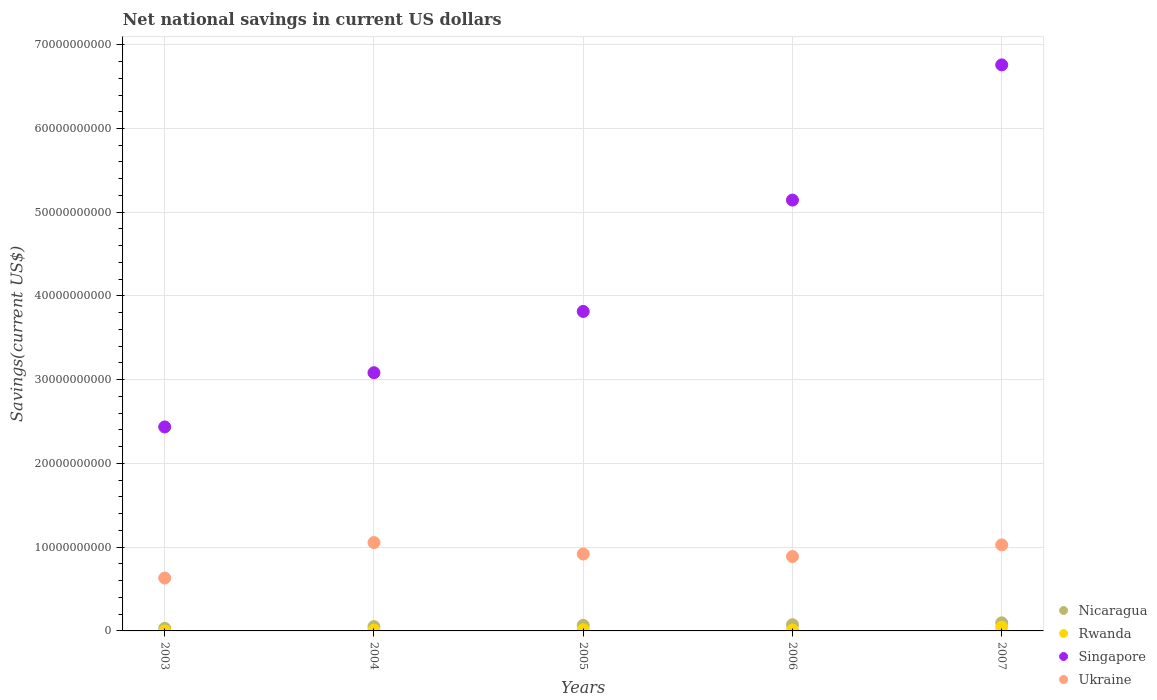What is the net national savings in Ukraine in 2006?
Make the answer very short. 8.88e+09. Across all years, what is the maximum net national savings in Rwanda?
Provide a short and direct response. 4.46e+08. Across all years, what is the minimum net national savings in Ukraine?
Provide a succinct answer. 6.32e+09. What is the total net national savings in Nicaragua in the graph?
Your answer should be compact. 3.19e+09. What is the difference between the net national savings in Singapore in 2003 and that in 2006?
Your answer should be compact. -2.71e+1. What is the difference between the net national savings in Nicaragua in 2006 and the net national savings in Rwanda in 2004?
Provide a short and direct response. 6.41e+08. What is the average net national savings in Ukraine per year?
Give a very brief answer. 9.04e+09. In the year 2006, what is the difference between the net national savings in Ukraine and net national savings in Nicaragua?
Ensure brevity in your answer.  8.14e+09. In how many years, is the net national savings in Ukraine greater than 30000000000 US$?
Your answer should be very brief. 0. What is the ratio of the net national savings in Ukraine in 2003 to that in 2007?
Offer a terse response. 0.61. What is the difference between the highest and the second highest net national savings in Nicaragua?
Your answer should be very brief. 2.22e+08. What is the difference between the highest and the lowest net national savings in Singapore?
Provide a succinct answer. 4.32e+1. Is the sum of the net national savings in Rwanda in 2004 and 2007 greater than the maximum net national savings in Ukraine across all years?
Offer a very short reply. No. Is it the case that in every year, the sum of the net national savings in Nicaragua and net national savings in Rwanda  is greater than the net national savings in Singapore?
Your answer should be very brief. No. How many dotlines are there?
Give a very brief answer. 4. What is the difference between two consecutive major ticks on the Y-axis?
Keep it short and to the point. 1.00e+1. Are the values on the major ticks of Y-axis written in scientific E-notation?
Ensure brevity in your answer.  No. Does the graph contain grids?
Make the answer very short. Yes. How many legend labels are there?
Keep it short and to the point. 4. How are the legend labels stacked?
Provide a succinct answer. Vertical. What is the title of the graph?
Keep it short and to the point. Net national savings in current US dollars. Does "Somalia" appear as one of the legend labels in the graph?
Ensure brevity in your answer.  No. What is the label or title of the Y-axis?
Offer a terse response. Savings(current US$). What is the Savings(current US$) of Nicaragua in 2003?
Offer a very short reply. 3.01e+08. What is the Savings(current US$) in Singapore in 2003?
Offer a terse response. 2.44e+1. What is the Savings(current US$) of Ukraine in 2003?
Make the answer very short. 6.32e+09. What is the Savings(current US$) in Nicaragua in 2004?
Ensure brevity in your answer.  5.14e+08. What is the Savings(current US$) of Rwanda in 2004?
Offer a terse response. 1.01e+08. What is the Savings(current US$) of Singapore in 2004?
Give a very brief answer. 3.08e+1. What is the Savings(current US$) in Ukraine in 2004?
Provide a succinct answer. 1.06e+1. What is the Savings(current US$) of Nicaragua in 2005?
Give a very brief answer. 6.65e+08. What is the Savings(current US$) of Rwanda in 2005?
Your response must be concise. 1.34e+08. What is the Savings(current US$) in Singapore in 2005?
Your response must be concise. 3.82e+1. What is the Savings(current US$) in Ukraine in 2005?
Your answer should be very brief. 9.18e+09. What is the Savings(current US$) of Nicaragua in 2006?
Provide a succinct answer. 7.42e+08. What is the Savings(current US$) in Rwanda in 2006?
Offer a very short reply. 9.64e+07. What is the Savings(current US$) in Singapore in 2006?
Keep it short and to the point. 5.14e+1. What is the Savings(current US$) of Ukraine in 2006?
Your answer should be compact. 8.88e+09. What is the Savings(current US$) of Nicaragua in 2007?
Keep it short and to the point. 9.64e+08. What is the Savings(current US$) of Rwanda in 2007?
Make the answer very short. 4.46e+08. What is the Savings(current US$) in Singapore in 2007?
Keep it short and to the point. 6.76e+1. What is the Savings(current US$) of Ukraine in 2007?
Provide a short and direct response. 1.03e+1. Across all years, what is the maximum Savings(current US$) in Nicaragua?
Keep it short and to the point. 9.64e+08. Across all years, what is the maximum Savings(current US$) in Rwanda?
Your response must be concise. 4.46e+08. Across all years, what is the maximum Savings(current US$) in Singapore?
Provide a short and direct response. 6.76e+1. Across all years, what is the maximum Savings(current US$) in Ukraine?
Offer a very short reply. 1.06e+1. Across all years, what is the minimum Savings(current US$) in Nicaragua?
Provide a short and direct response. 3.01e+08. Across all years, what is the minimum Savings(current US$) of Rwanda?
Provide a short and direct response. 0. Across all years, what is the minimum Savings(current US$) of Singapore?
Give a very brief answer. 2.44e+1. Across all years, what is the minimum Savings(current US$) in Ukraine?
Provide a short and direct response. 6.32e+09. What is the total Savings(current US$) of Nicaragua in the graph?
Your answer should be compact. 3.19e+09. What is the total Savings(current US$) of Rwanda in the graph?
Make the answer very short. 7.78e+08. What is the total Savings(current US$) in Singapore in the graph?
Make the answer very short. 2.12e+11. What is the total Savings(current US$) of Ukraine in the graph?
Make the answer very short. 4.52e+1. What is the difference between the Savings(current US$) in Nicaragua in 2003 and that in 2004?
Keep it short and to the point. -2.13e+08. What is the difference between the Savings(current US$) in Singapore in 2003 and that in 2004?
Provide a succinct answer. -6.47e+09. What is the difference between the Savings(current US$) of Ukraine in 2003 and that in 2004?
Keep it short and to the point. -4.24e+09. What is the difference between the Savings(current US$) of Nicaragua in 2003 and that in 2005?
Give a very brief answer. -3.64e+08. What is the difference between the Savings(current US$) in Singapore in 2003 and that in 2005?
Provide a short and direct response. -1.38e+1. What is the difference between the Savings(current US$) in Ukraine in 2003 and that in 2005?
Provide a succinct answer. -2.87e+09. What is the difference between the Savings(current US$) in Nicaragua in 2003 and that in 2006?
Your answer should be very brief. -4.42e+08. What is the difference between the Savings(current US$) in Singapore in 2003 and that in 2006?
Provide a short and direct response. -2.71e+1. What is the difference between the Savings(current US$) in Ukraine in 2003 and that in 2006?
Offer a terse response. -2.57e+09. What is the difference between the Savings(current US$) in Nicaragua in 2003 and that in 2007?
Your response must be concise. -6.64e+08. What is the difference between the Savings(current US$) of Singapore in 2003 and that in 2007?
Offer a very short reply. -4.32e+1. What is the difference between the Savings(current US$) of Ukraine in 2003 and that in 2007?
Make the answer very short. -3.96e+09. What is the difference between the Savings(current US$) in Nicaragua in 2004 and that in 2005?
Provide a short and direct response. -1.51e+08. What is the difference between the Savings(current US$) in Rwanda in 2004 and that in 2005?
Your answer should be very brief. -3.28e+07. What is the difference between the Savings(current US$) of Singapore in 2004 and that in 2005?
Offer a very short reply. -7.32e+09. What is the difference between the Savings(current US$) of Ukraine in 2004 and that in 2005?
Keep it short and to the point. 1.37e+09. What is the difference between the Savings(current US$) in Nicaragua in 2004 and that in 2006?
Offer a terse response. -2.28e+08. What is the difference between the Savings(current US$) of Rwanda in 2004 and that in 2006?
Your answer should be very brief. 4.93e+06. What is the difference between the Savings(current US$) in Singapore in 2004 and that in 2006?
Provide a short and direct response. -2.06e+1. What is the difference between the Savings(current US$) of Ukraine in 2004 and that in 2006?
Ensure brevity in your answer.  1.67e+09. What is the difference between the Savings(current US$) of Nicaragua in 2004 and that in 2007?
Make the answer very short. -4.50e+08. What is the difference between the Savings(current US$) in Rwanda in 2004 and that in 2007?
Provide a succinct answer. -3.45e+08. What is the difference between the Savings(current US$) in Singapore in 2004 and that in 2007?
Your response must be concise. -3.68e+1. What is the difference between the Savings(current US$) of Ukraine in 2004 and that in 2007?
Your response must be concise. 2.78e+08. What is the difference between the Savings(current US$) in Nicaragua in 2005 and that in 2006?
Offer a very short reply. -7.71e+07. What is the difference between the Savings(current US$) in Rwanda in 2005 and that in 2006?
Your answer should be very brief. 3.77e+07. What is the difference between the Savings(current US$) of Singapore in 2005 and that in 2006?
Make the answer very short. -1.33e+1. What is the difference between the Savings(current US$) of Ukraine in 2005 and that in 2006?
Provide a short and direct response. 2.99e+08. What is the difference between the Savings(current US$) of Nicaragua in 2005 and that in 2007?
Provide a succinct answer. -2.99e+08. What is the difference between the Savings(current US$) of Rwanda in 2005 and that in 2007?
Provide a short and direct response. -3.12e+08. What is the difference between the Savings(current US$) in Singapore in 2005 and that in 2007?
Provide a short and direct response. -2.94e+1. What is the difference between the Savings(current US$) of Ukraine in 2005 and that in 2007?
Your response must be concise. -1.09e+09. What is the difference between the Savings(current US$) of Nicaragua in 2006 and that in 2007?
Your answer should be compact. -2.22e+08. What is the difference between the Savings(current US$) of Rwanda in 2006 and that in 2007?
Your answer should be very brief. -3.50e+08. What is the difference between the Savings(current US$) of Singapore in 2006 and that in 2007?
Provide a short and direct response. -1.61e+1. What is the difference between the Savings(current US$) of Ukraine in 2006 and that in 2007?
Offer a terse response. -1.39e+09. What is the difference between the Savings(current US$) of Nicaragua in 2003 and the Savings(current US$) of Rwanda in 2004?
Your answer should be very brief. 1.99e+08. What is the difference between the Savings(current US$) in Nicaragua in 2003 and the Savings(current US$) in Singapore in 2004?
Ensure brevity in your answer.  -3.05e+1. What is the difference between the Savings(current US$) of Nicaragua in 2003 and the Savings(current US$) of Ukraine in 2004?
Keep it short and to the point. -1.03e+1. What is the difference between the Savings(current US$) in Singapore in 2003 and the Savings(current US$) in Ukraine in 2004?
Provide a succinct answer. 1.38e+1. What is the difference between the Savings(current US$) of Nicaragua in 2003 and the Savings(current US$) of Rwanda in 2005?
Keep it short and to the point. 1.67e+08. What is the difference between the Savings(current US$) in Nicaragua in 2003 and the Savings(current US$) in Singapore in 2005?
Provide a succinct answer. -3.79e+1. What is the difference between the Savings(current US$) in Nicaragua in 2003 and the Savings(current US$) in Ukraine in 2005?
Your response must be concise. -8.88e+09. What is the difference between the Savings(current US$) in Singapore in 2003 and the Savings(current US$) in Ukraine in 2005?
Your response must be concise. 1.52e+1. What is the difference between the Savings(current US$) in Nicaragua in 2003 and the Savings(current US$) in Rwanda in 2006?
Your answer should be very brief. 2.04e+08. What is the difference between the Savings(current US$) of Nicaragua in 2003 and the Savings(current US$) of Singapore in 2006?
Your answer should be very brief. -5.11e+1. What is the difference between the Savings(current US$) in Nicaragua in 2003 and the Savings(current US$) in Ukraine in 2006?
Provide a short and direct response. -8.58e+09. What is the difference between the Savings(current US$) in Singapore in 2003 and the Savings(current US$) in Ukraine in 2006?
Offer a terse response. 1.55e+1. What is the difference between the Savings(current US$) of Nicaragua in 2003 and the Savings(current US$) of Rwanda in 2007?
Keep it short and to the point. -1.45e+08. What is the difference between the Savings(current US$) of Nicaragua in 2003 and the Savings(current US$) of Singapore in 2007?
Keep it short and to the point. -6.73e+1. What is the difference between the Savings(current US$) in Nicaragua in 2003 and the Savings(current US$) in Ukraine in 2007?
Give a very brief answer. -9.97e+09. What is the difference between the Savings(current US$) of Singapore in 2003 and the Savings(current US$) of Ukraine in 2007?
Provide a succinct answer. 1.41e+1. What is the difference between the Savings(current US$) in Nicaragua in 2004 and the Savings(current US$) in Rwanda in 2005?
Offer a very short reply. 3.80e+08. What is the difference between the Savings(current US$) in Nicaragua in 2004 and the Savings(current US$) in Singapore in 2005?
Your response must be concise. -3.76e+1. What is the difference between the Savings(current US$) of Nicaragua in 2004 and the Savings(current US$) of Ukraine in 2005?
Ensure brevity in your answer.  -8.67e+09. What is the difference between the Savings(current US$) in Rwanda in 2004 and the Savings(current US$) in Singapore in 2005?
Provide a short and direct response. -3.81e+1. What is the difference between the Savings(current US$) in Rwanda in 2004 and the Savings(current US$) in Ukraine in 2005?
Offer a terse response. -9.08e+09. What is the difference between the Savings(current US$) in Singapore in 2004 and the Savings(current US$) in Ukraine in 2005?
Offer a very short reply. 2.17e+1. What is the difference between the Savings(current US$) of Nicaragua in 2004 and the Savings(current US$) of Rwanda in 2006?
Your answer should be compact. 4.18e+08. What is the difference between the Savings(current US$) in Nicaragua in 2004 and the Savings(current US$) in Singapore in 2006?
Make the answer very short. -5.09e+1. What is the difference between the Savings(current US$) of Nicaragua in 2004 and the Savings(current US$) of Ukraine in 2006?
Give a very brief answer. -8.37e+09. What is the difference between the Savings(current US$) in Rwanda in 2004 and the Savings(current US$) in Singapore in 2006?
Ensure brevity in your answer.  -5.13e+1. What is the difference between the Savings(current US$) in Rwanda in 2004 and the Savings(current US$) in Ukraine in 2006?
Your answer should be compact. -8.78e+09. What is the difference between the Savings(current US$) in Singapore in 2004 and the Savings(current US$) in Ukraine in 2006?
Offer a terse response. 2.20e+1. What is the difference between the Savings(current US$) in Nicaragua in 2004 and the Savings(current US$) in Rwanda in 2007?
Provide a succinct answer. 6.77e+07. What is the difference between the Savings(current US$) in Nicaragua in 2004 and the Savings(current US$) in Singapore in 2007?
Make the answer very short. -6.71e+1. What is the difference between the Savings(current US$) of Nicaragua in 2004 and the Savings(current US$) of Ukraine in 2007?
Give a very brief answer. -9.76e+09. What is the difference between the Savings(current US$) in Rwanda in 2004 and the Savings(current US$) in Singapore in 2007?
Your answer should be very brief. -6.75e+1. What is the difference between the Savings(current US$) in Rwanda in 2004 and the Savings(current US$) in Ukraine in 2007?
Provide a short and direct response. -1.02e+1. What is the difference between the Savings(current US$) in Singapore in 2004 and the Savings(current US$) in Ukraine in 2007?
Make the answer very short. 2.06e+1. What is the difference between the Savings(current US$) in Nicaragua in 2005 and the Savings(current US$) in Rwanda in 2006?
Provide a short and direct response. 5.69e+08. What is the difference between the Savings(current US$) in Nicaragua in 2005 and the Savings(current US$) in Singapore in 2006?
Offer a terse response. -5.08e+1. What is the difference between the Savings(current US$) of Nicaragua in 2005 and the Savings(current US$) of Ukraine in 2006?
Provide a short and direct response. -8.22e+09. What is the difference between the Savings(current US$) of Rwanda in 2005 and the Savings(current US$) of Singapore in 2006?
Make the answer very short. -5.13e+1. What is the difference between the Savings(current US$) of Rwanda in 2005 and the Savings(current US$) of Ukraine in 2006?
Your answer should be compact. -8.75e+09. What is the difference between the Savings(current US$) of Singapore in 2005 and the Savings(current US$) of Ukraine in 2006?
Your answer should be very brief. 2.93e+1. What is the difference between the Savings(current US$) of Nicaragua in 2005 and the Savings(current US$) of Rwanda in 2007?
Your answer should be very brief. 2.19e+08. What is the difference between the Savings(current US$) of Nicaragua in 2005 and the Savings(current US$) of Singapore in 2007?
Offer a terse response. -6.69e+1. What is the difference between the Savings(current US$) of Nicaragua in 2005 and the Savings(current US$) of Ukraine in 2007?
Offer a terse response. -9.61e+09. What is the difference between the Savings(current US$) in Rwanda in 2005 and the Savings(current US$) in Singapore in 2007?
Your answer should be compact. -6.75e+1. What is the difference between the Savings(current US$) of Rwanda in 2005 and the Savings(current US$) of Ukraine in 2007?
Keep it short and to the point. -1.01e+1. What is the difference between the Savings(current US$) in Singapore in 2005 and the Savings(current US$) in Ukraine in 2007?
Offer a very short reply. 2.79e+1. What is the difference between the Savings(current US$) of Nicaragua in 2006 and the Savings(current US$) of Rwanda in 2007?
Your response must be concise. 2.96e+08. What is the difference between the Savings(current US$) in Nicaragua in 2006 and the Savings(current US$) in Singapore in 2007?
Ensure brevity in your answer.  -6.69e+1. What is the difference between the Savings(current US$) in Nicaragua in 2006 and the Savings(current US$) in Ukraine in 2007?
Your response must be concise. -9.53e+09. What is the difference between the Savings(current US$) of Rwanda in 2006 and the Savings(current US$) of Singapore in 2007?
Your response must be concise. -6.75e+1. What is the difference between the Savings(current US$) in Rwanda in 2006 and the Savings(current US$) in Ukraine in 2007?
Ensure brevity in your answer.  -1.02e+1. What is the difference between the Savings(current US$) of Singapore in 2006 and the Savings(current US$) of Ukraine in 2007?
Make the answer very short. 4.12e+1. What is the average Savings(current US$) of Nicaragua per year?
Your response must be concise. 6.37e+08. What is the average Savings(current US$) of Rwanda per year?
Offer a very short reply. 1.56e+08. What is the average Savings(current US$) of Singapore per year?
Keep it short and to the point. 4.25e+1. What is the average Savings(current US$) in Ukraine per year?
Give a very brief answer. 9.04e+09. In the year 2003, what is the difference between the Savings(current US$) in Nicaragua and Savings(current US$) in Singapore?
Keep it short and to the point. -2.41e+1. In the year 2003, what is the difference between the Savings(current US$) in Nicaragua and Savings(current US$) in Ukraine?
Provide a succinct answer. -6.02e+09. In the year 2003, what is the difference between the Savings(current US$) in Singapore and Savings(current US$) in Ukraine?
Your answer should be very brief. 1.80e+1. In the year 2004, what is the difference between the Savings(current US$) of Nicaragua and Savings(current US$) of Rwanda?
Your answer should be very brief. 4.13e+08. In the year 2004, what is the difference between the Savings(current US$) of Nicaragua and Savings(current US$) of Singapore?
Your response must be concise. -3.03e+1. In the year 2004, what is the difference between the Savings(current US$) of Nicaragua and Savings(current US$) of Ukraine?
Make the answer very short. -1.00e+1. In the year 2004, what is the difference between the Savings(current US$) in Rwanda and Savings(current US$) in Singapore?
Give a very brief answer. -3.07e+1. In the year 2004, what is the difference between the Savings(current US$) in Rwanda and Savings(current US$) in Ukraine?
Ensure brevity in your answer.  -1.05e+1. In the year 2004, what is the difference between the Savings(current US$) in Singapore and Savings(current US$) in Ukraine?
Keep it short and to the point. 2.03e+1. In the year 2005, what is the difference between the Savings(current US$) in Nicaragua and Savings(current US$) in Rwanda?
Offer a terse response. 5.31e+08. In the year 2005, what is the difference between the Savings(current US$) of Nicaragua and Savings(current US$) of Singapore?
Your answer should be compact. -3.75e+1. In the year 2005, what is the difference between the Savings(current US$) of Nicaragua and Savings(current US$) of Ukraine?
Provide a succinct answer. -8.52e+09. In the year 2005, what is the difference between the Savings(current US$) in Rwanda and Savings(current US$) in Singapore?
Make the answer very short. -3.80e+1. In the year 2005, what is the difference between the Savings(current US$) of Rwanda and Savings(current US$) of Ukraine?
Give a very brief answer. -9.05e+09. In the year 2005, what is the difference between the Savings(current US$) in Singapore and Savings(current US$) in Ukraine?
Your answer should be very brief. 2.90e+1. In the year 2006, what is the difference between the Savings(current US$) of Nicaragua and Savings(current US$) of Rwanda?
Give a very brief answer. 6.46e+08. In the year 2006, what is the difference between the Savings(current US$) of Nicaragua and Savings(current US$) of Singapore?
Offer a very short reply. -5.07e+1. In the year 2006, what is the difference between the Savings(current US$) in Nicaragua and Savings(current US$) in Ukraine?
Your answer should be very brief. -8.14e+09. In the year 2006, what is the difference between the Savings(current US$) in Rwanda and Savings(current US$) in Singapore?
Your answer should be compact. -5.14e+1. In the year 2006, what is the difference between the Savings(current US$) in Rwanda and Savings(current US$) in Ukraine?
Give a very brief answer. -8.79e+09. In the year 2006, what is the difference between the Savings(current US$) of Singapore and Savings(current US$) of Ukraine?
Keep it short and to the point. 4.26e+1. In the year 2007, what is the difference between the Savings(current US$) of Nicaragua and Savings(current US$) of Rwanda?
Provide a succinct answer. 5.18e+08. In the year 2007, what is the difference between the Savings(current US$) of Nicaragua and Savings(current US$) of Singapore?
Your answer should be compact. -6.66e+1. In the year 2007, what is the difference between the Savings(current US$) of Nicaragua and Savings(current US$) of Ukraine?
Keep it short and to the point. -9.31e+09. In the year 2007, what is the difference between the Savings(current US$) of Rwanda and Savings(current US$) of Singapore?
Your answer should be very brief. -6.72e+1. In the year 2007, what is the difference between the Savings(current US$) in Rwanda and Savings(current US$) in Ukraine?
Provide a succinct answer. -9.83e+09. In the year 2007, what is the difference between the Savings(current US$) of Singapore and Savings(current US$) of Ukraine?
Your answer should be compact. 5.73e+1. What is the ratio of the Savings(current US$) of Nicaragua in 2003 to that in 2004?
Keep it short and to the point. 0.59. What is the ratio of the Savings(current US$) in Singapore in 2003 to that in 2004?
Your answer should be compact. 0.79. What is the ratio of the Savings(current US$) of Ukraine in 2003 to that in 2004?
Provide a succinct answer. 0.6. What is the ratio of the Savings(current US$) in Nicaragua in 2003 to that in 2005?
Offer a very short reply. 0.45. What is the ratio of the Savings(current US$) in Singapore in 2003 to that in 2005?
Your response must be concise. 0.64. What is the ratio of the Savings(current US$) of Ukraine in 2003 to that in 2005?
Offer a terse response. 0.69. What is the ratio of the Savings(current US$) in Nicaragua in 2003 to that in 2006?
Make the answer very short. 0.41. What is the ratio of the Savings(current US$) of Singapore in 2003 to that in 2006?
Offer a terse response. 0.47. What is the ratio of the Savings(current US$) of Ukraine in 2003 to that in 2006?
Your answer should be very brief. 0.71. What is the ratio of the Savings(current US$) in Nicaragua in 2003 to that in 2007?
Keep it short and to the point. 0.31. What is the ratio of the Savings(current US$) in Singapore in 2003 to that in 2007?
Your answer should be very brief. 0.36. What is the ratio of the Savings(current US$) in Ukraine in 2003 to that in 2007?
Give a very brief answer. 0.61. What is the ratio of the Savings(current US$) of Nicaragua in 2004 to that in 2005?
Your answer should be very brief. 0.77. What is the ratio of the Savings(current US$) in Rwanda in 2004 to that in 2005?
Offer a very short reply. 0.76. What is the ratio of the Savings(current US$) of Singapore in 2004 to that in 2005?
Offer a very short reply. 0.81. What is the ratio of the Savings(current US$) of Ukraine in 2004 to that in 2005?
Offer a terse response. 1.15. What is the ratio of the Savings(current US$) in Nicaragua in 2004 to that in 2006?
Offer a terse response. 0.69. What is the ratio of the Savings(current US$) in Rwanda in 2004 to that in 2006?
Provide a succinct answer. 1.05. What is the ratio of the Savings(current US$) of Singapore in 2004 to that in 2006?
Keep it short and to the point. 0.6. What is the ratio of the Savings(current US$) of Ukraine in 2004 to that in 2006?
Offer a very short reply. 1.19. What is the ratio of the Savings(current US$) in Nicaragua in 2004 to that in 2007?
Keep it short and to the point. 0.53. What is the ratio of the Savings(current US$) of Rwanda in 2004 to that in 2007?
Provide a succinct answer. 0.23. What is the ratio of the Savings(current US$) in Singapore in 2004 to that in 2007?
Your answer should be very brief. 0.46. What is the ratio of the Savings(current US$) in Ukraine in 2004 to that in 2007?
Make the answer very short. 1.03. What is the ratio of the Savings(current US$) of Nicaragua in 2005 to that in 2006?
Keep it short and to the point. 0.9. What is the ratio of the Savings(current US$) of Rwanda in 2005 to that in 2006?
Your answer should be very brief. 1.39. What is the ratio of the Savings(current US$) of Singapore in 2005 to that in 2006?
Offer a terse response. 0.74. What is the ratio of the Savings(current US$) of Ukraine in 2005 to that in 2006?
Provide a succinct answer. 1.03. What is the ratio of the Savings(current US$) of Nicaragua in 2005 to that in 2007?
Offer a very short reply. 0.69. What is the ratio of the Savings(current US$) of Rwanda in 2005 to that in 2007?
Give a very brief answer. 0.3. What is the ratio of the Savings(current US$) in Singapore in 2005 to that in 2007?
Ensure brevity in your answer.  0.56. What is the ratio of the Savings(current US$) in Ukraine in 2005 to that in 2007?
Your answer should be compact. 0.89. What is the ratio of the Savings(current US$) of Nicaragua in 2006 to that in 2007?
Keep it short and to the point. 0.77. What is the ratio of the Savings(current US$) in Rwanda in 2006 to that in 2007?
Provide a short and direct response. 0.22. What is the ratio of the Savings(current US$) of Singapore in 2006 to that in 2007?
Your response must be concise. 0.76. What is the ratio of the Savings(current US$) of Ukraine in 2006 to that in 2007?
Your answer should be compact. 0.86. What is the difference between the highest and the second highest Savings(current US$) of Nicaragua?
Your answer should be compact. 2.22e+08. What is the difference between the highest and the second highest Savings(current US$) of Rwanda?
Provide a succinct answer. 3.12e+08. What is the difference between the highest and the second highest Savings(current US$) in Singapore?
Give a very brief answer. 1.61e+1. What is the difference between the highest and the second highest Savings(current US$) in Ukraine?
Offer a very short reply. 2.78e+08. What is the difference between the highest and the lowest Savings(current US$) of Nicaragua?
Your answer should be very brief. 6.64e+08. What is the difference between the highest and the lowest Savings(current US$) of Rwanda?
Ensure brevity in your answer.  4.46e+08. What is the difference between the highest and the lowest Savings(current US$) of Singapore?
Your answer should be very brief. 4.32e+1. What is the difference between the highest and the lowest Savings(current US$) of Ukraine?
Your response must be concise. 4.24e+09. 